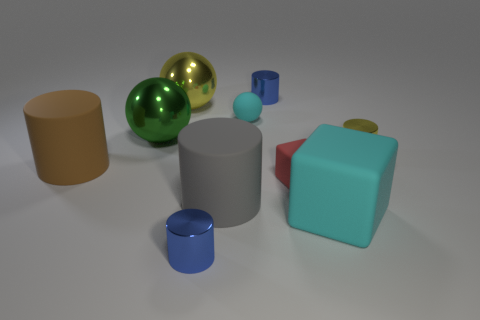What materials do the objects seem to be made of? The objects in the image appear to have various materials. The spheres have a reflective, perhaps metallic, surface, indicating they could be made of polished metal. The cylinders and cube, with their matte surfaces, suggest a plastic or rubber-like material. 